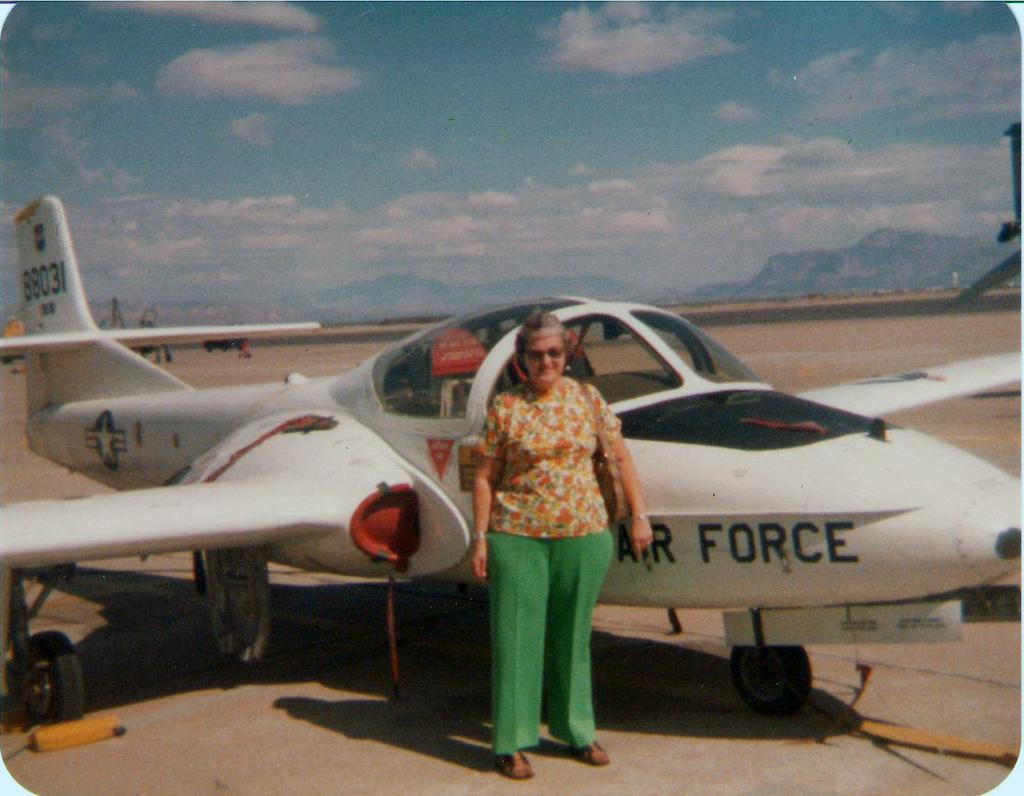<image>
Share a concise interpretation of the image provided. An older woman stands next to a white Air Force jet. 